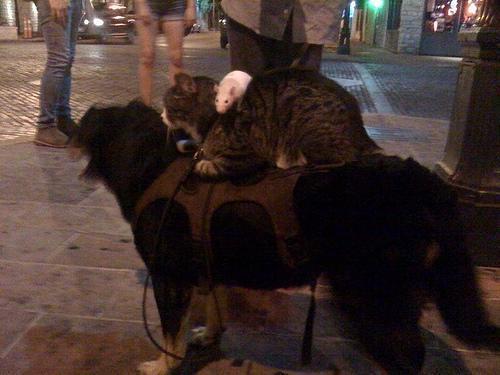How many people are in the picture?
Give a very brief answer. 3. 